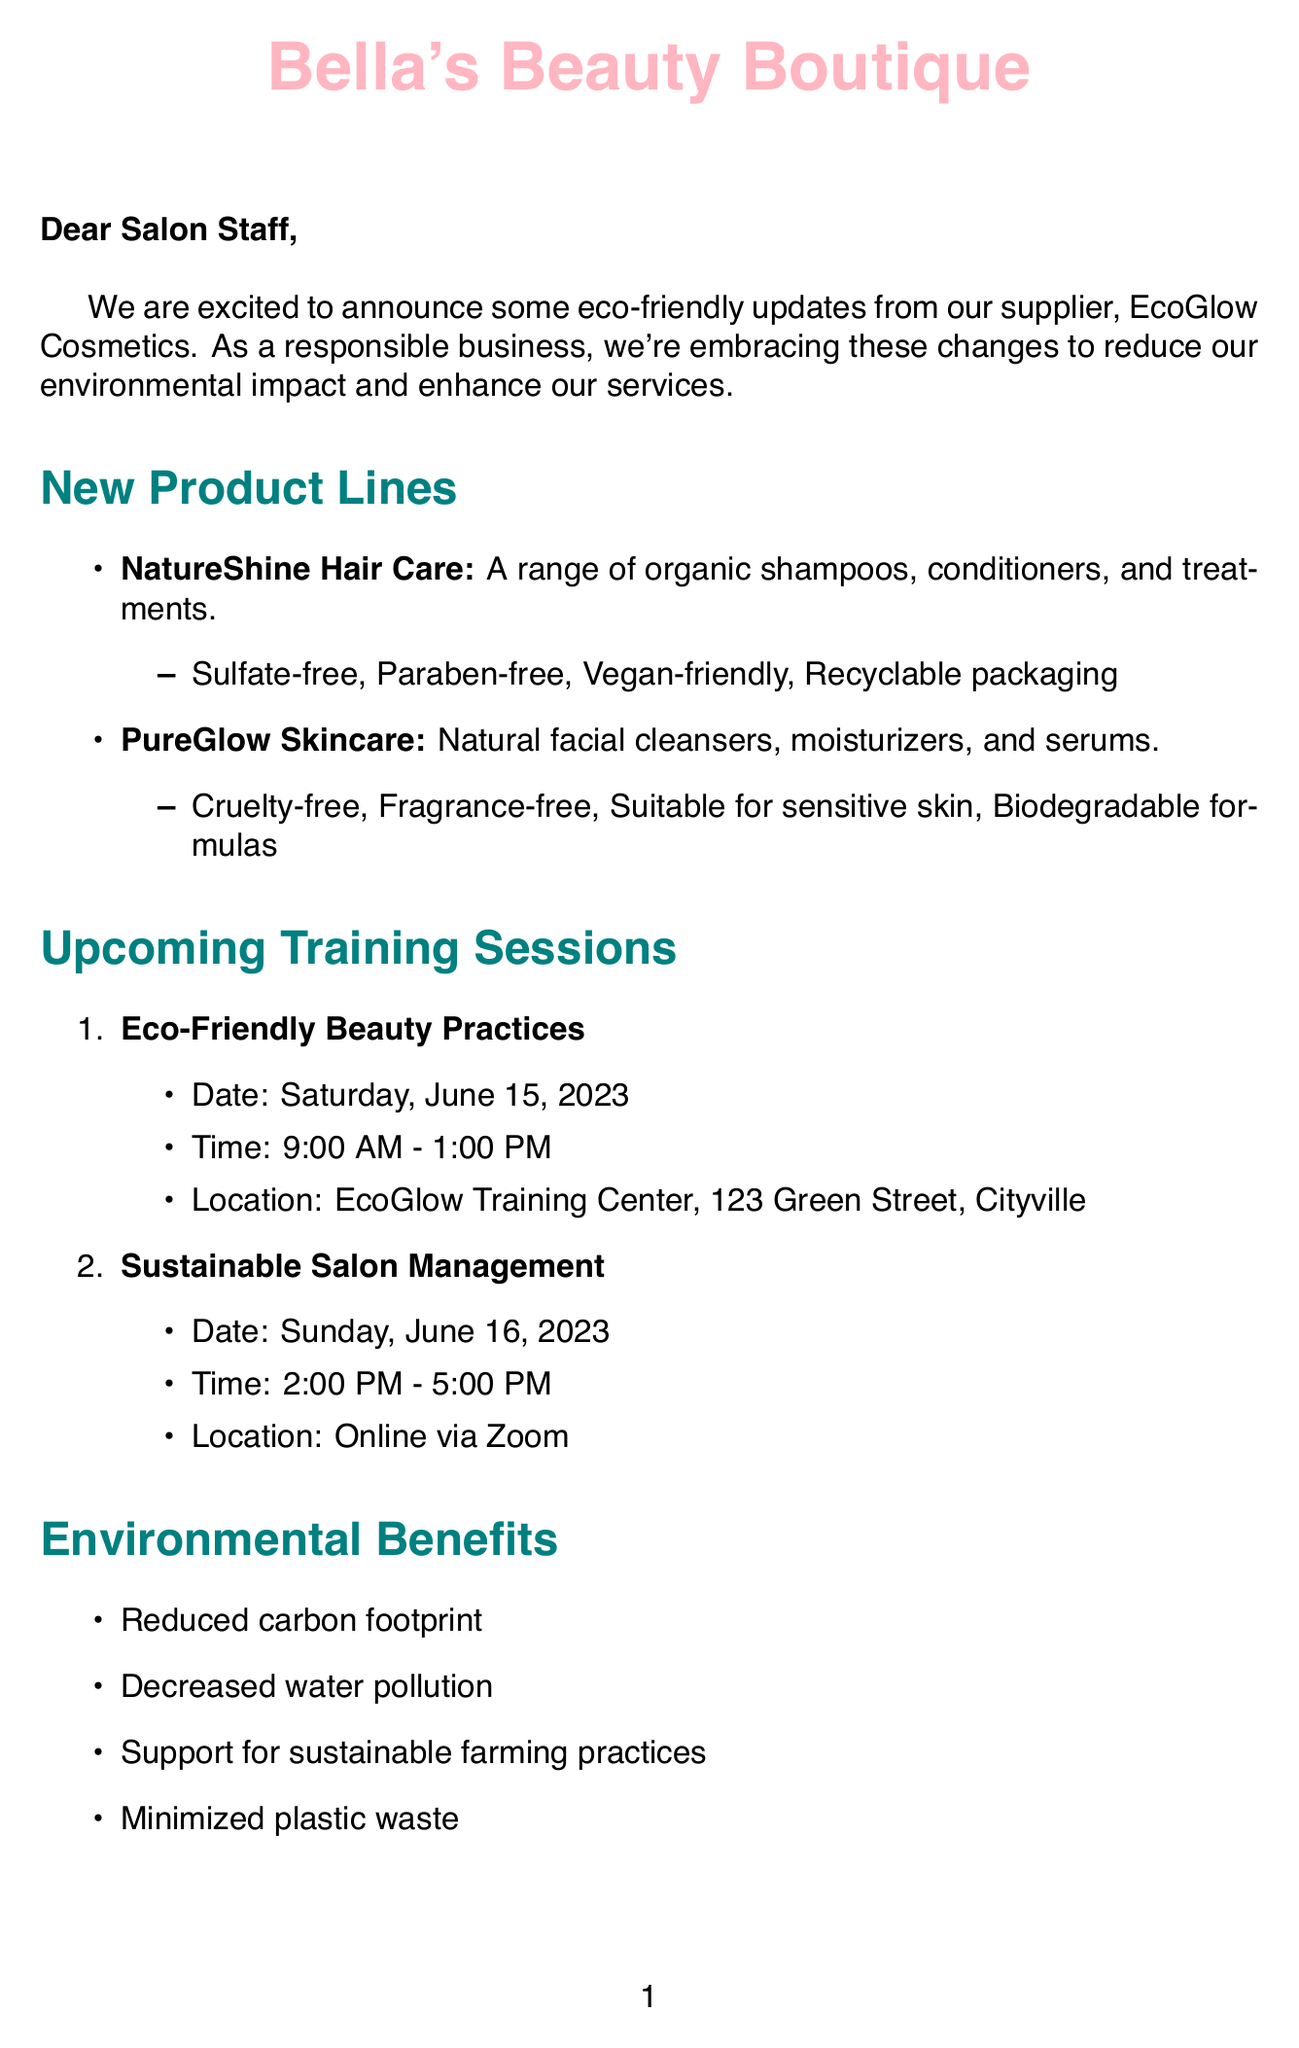What is the name of the supplier? The supplier of the beauty salon is mentioned in the document as EcoGlow Cosmetics.
Answer: EcoGlow Cosmetics What is the date of the first training session? The document specifies the date of the first training session on eco-friendly practices, which is Saturday, June 15, 2023.
Answer: Saturday, June 15, 2023 What is the key feature of the NatureShine Hair Care line? The NatureShine Hair Care line includes several features, one of which is that it is sulfate-free.
Answer: Sulfate-free What is one environmental benefit mentioned in the document? The letter lists various environmental benefits, one of which is reduced carbon footprint.
Answer: Reduced carbon footprint How long is the Eco-Friendly Beauty Practices training session? The document states the duration of the Eco-Friendly Beauty Practices training session is 4 hours.
Answer: 4 hours What is one required action after receiving this letter? The document lists several required actions, one of which is to review new product catalogs.
Answer: Review new product catalogs What time does the Sustainable Salon Management session start? The document provides the time for the Sustainable Salon Management session, which is 2:00 PM.
Answer: 2:00 PM Who is the contact person for questions regarding the new products? The document identifies Sarah Green as the contact person for inquiries.
Answer: Sarah Green What is a business advantage mentioned in the document? The document outlines several business advantages, including attracting eco-conscious customers.
Answer: Attract eco-conscious customers 